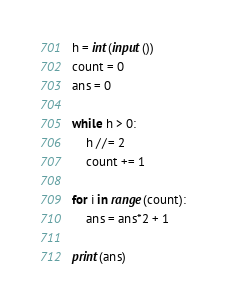Convert code to text. <code><loc_0><loc_0><loc_500><loc_500><_Python_>h = int(input())
count = 0
ans = 0

while h > 0:
    h //= 2
    count += 1

for i in range(count):
    ans = ans*2 + 1

print(ans)</code> 